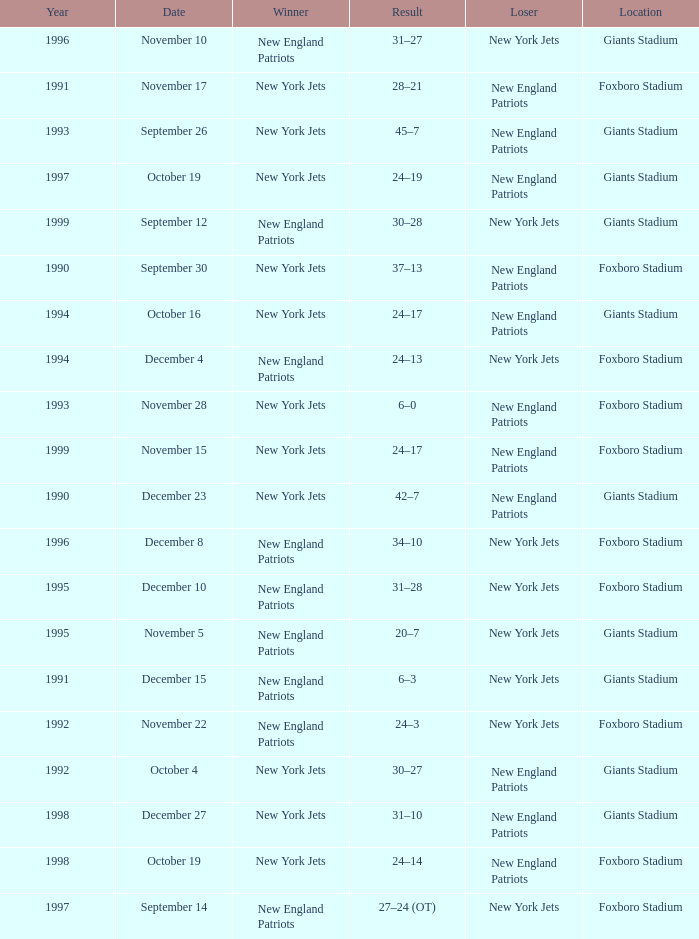What team was the lower when the winner was the new york jets, and a Year earlier than 1994, and a Result of 37–13? New England Patriots. 